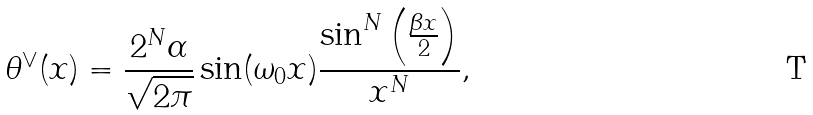Convert formula to latex. <formula><loc_0><loc_0><loc_500><loc_500>\theta ^ { \vee } ( x ) = \frac { 2 ^ { N } \alpha } { \sqrt { 2 \pi } } \sin ( \omega _ { 0 } x ) \frac { \sin ^ { N } \left ( \frac { \beta x } { 2 } \right ) } { x ^ { N } } ,</formula> 